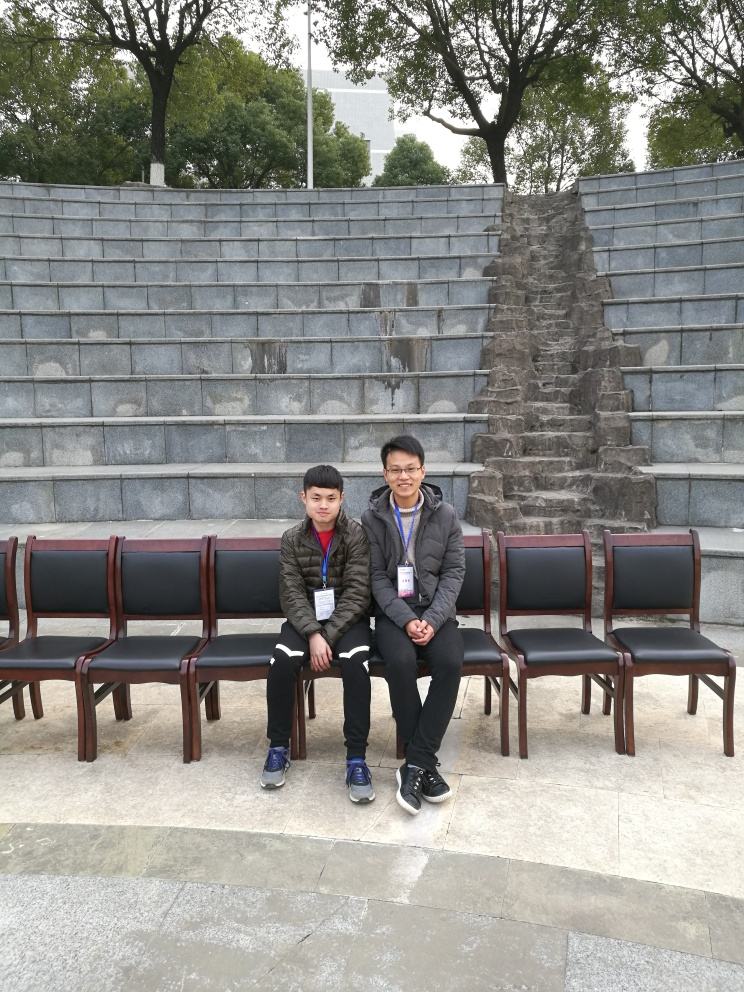Is the horizon parallel to the bottom of the frame?
A. Yes
B. No
Answer with the option's letter from the given choices directly.
 A. 